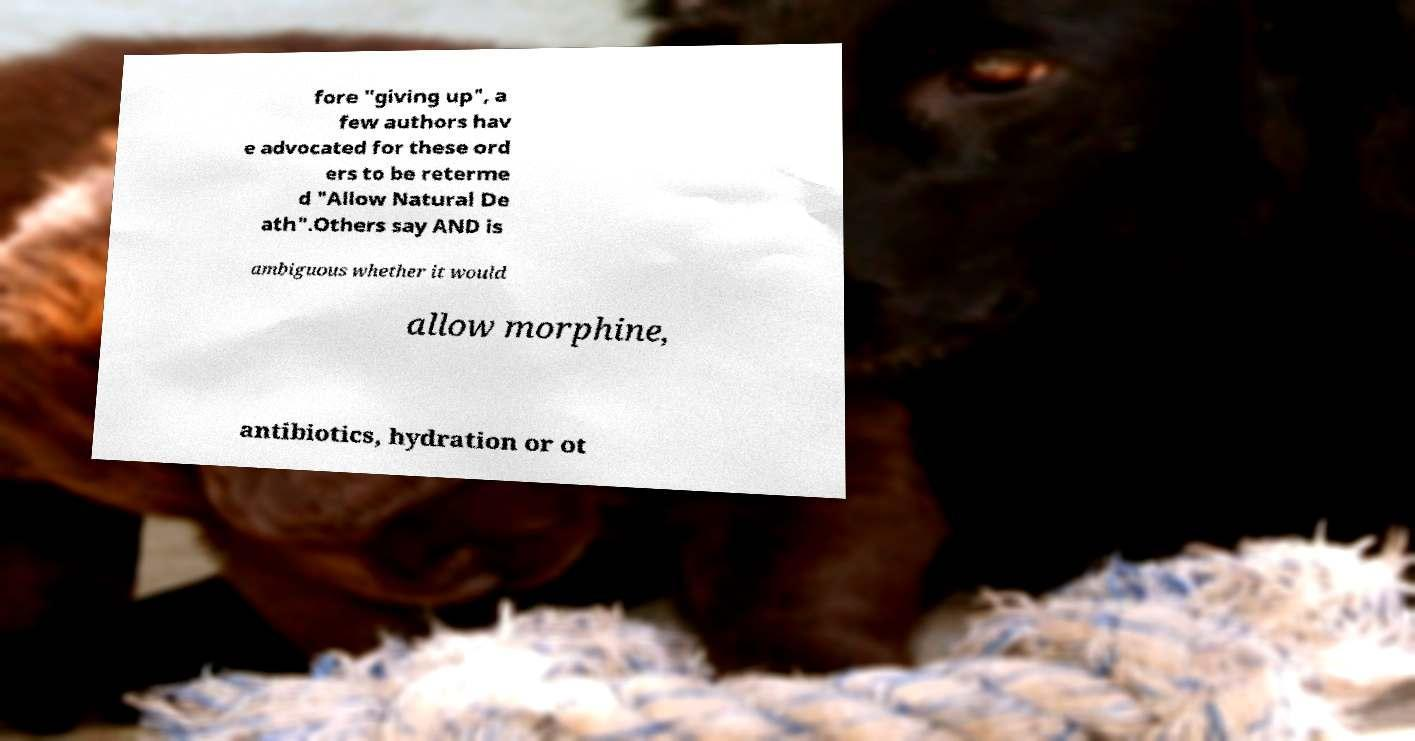Could you extract and type out the text from this image? fore "giving up", a few authors hav e advocated for these ord ers to be reterme d "Allow Natural De ath".Others say AND is ambiguous whether it would allow morphine, antibiotics, hydration or ot 